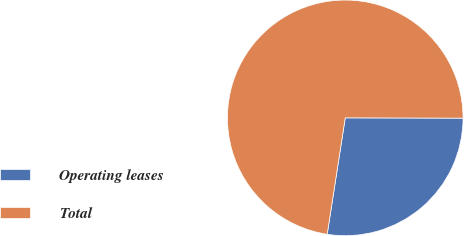Convert chart. <chart><loc_0><loc_0><loc_500><loc_500><pie_chart><fcel>Operating leases<fcel>Total<nl><fcel>27.41%<fcel>72.59%<nl></chart> 